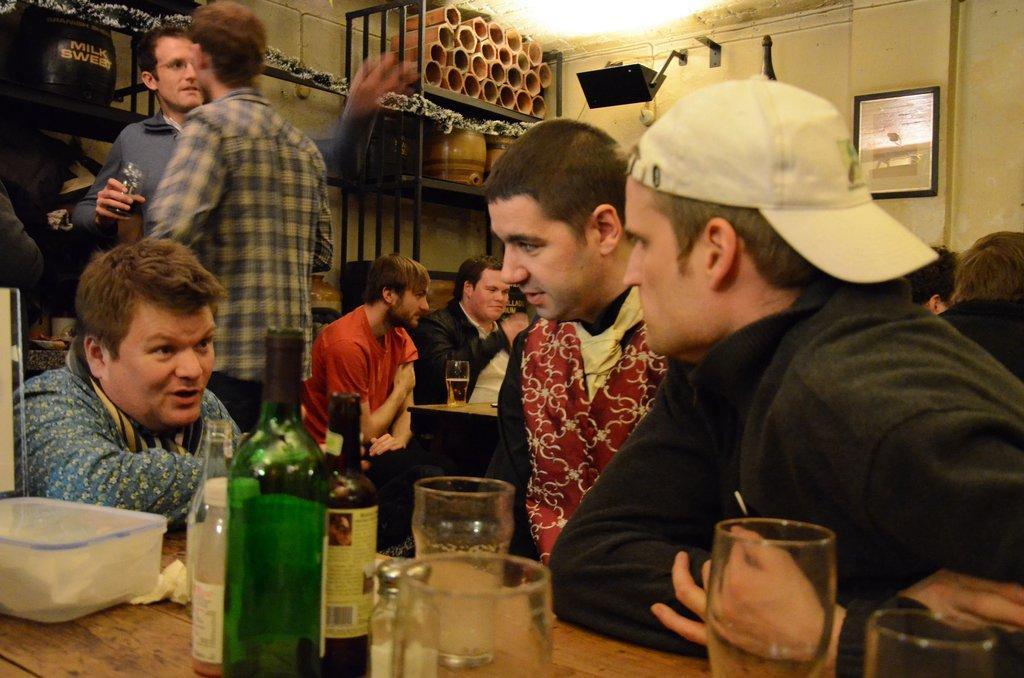Could you give a brief overview of what you see in this image? In this picture there are group of people who are siting on the chair. There are two men who are standing. There is a bottle, glass and a bottle on the table. There is a rack and few objects in the rack. There is a frame on the wall. 